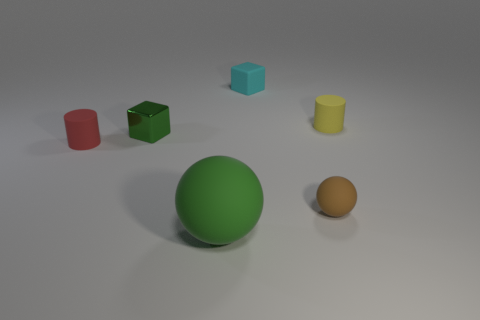Add 2 yellow cylinders. How many objects exist? 8 Subtract all cylinders. How many objects are left? 4 Subtract all brown balls. Subtract all small green things. How many objects are left? 4 Add 1 cyan rubber objects. How many cyan rubber objects are left? 2 Add 4 yellow things. How many yellow things exist? 5 Subtract 1 green blocks. How many objects are left? 5 Subtract all brown blocks. Subtract all red spheres. How many blocks are left? 2 